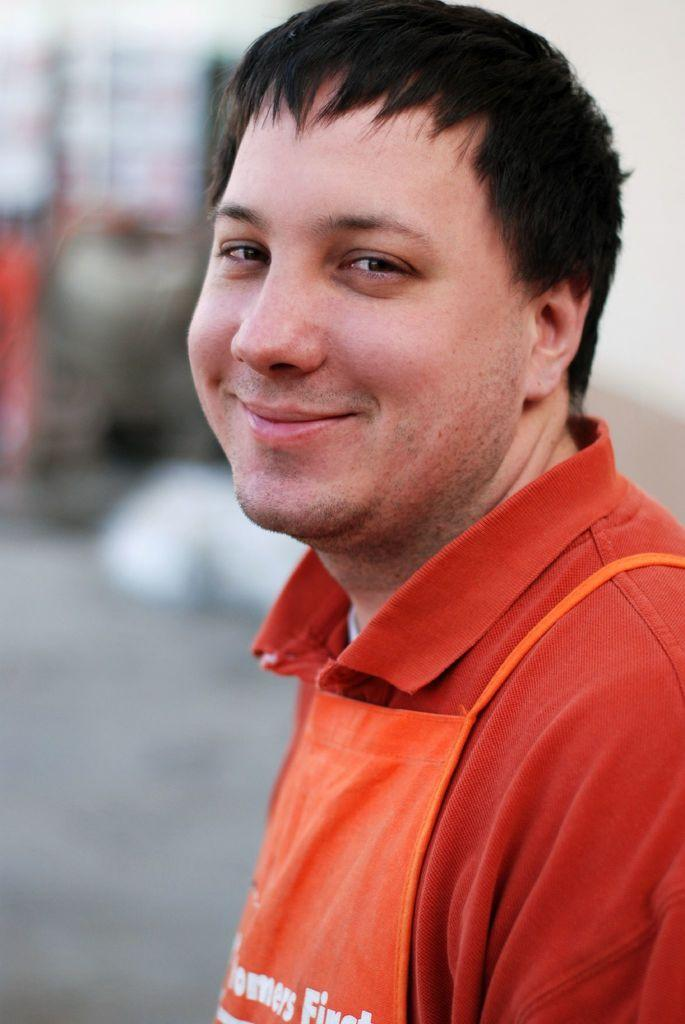Who is present in the image? There is a man in the image. What is the man doing in the image? The man is standing in the image. What is the man's facial expression in the image? The man is smiling in the image. Can you describe the background of the image? The background of the image is blurred. What type of cent is visible in the image? There is no cent present in the image. What is the man's need in the image? The image does not provide information about the man's needs or desires. 